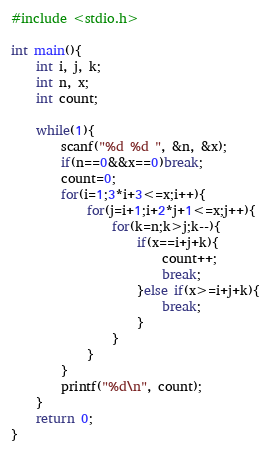<code> <loc_0><loc_0><loc_500><loc_500><_C_>#include <stdio.h>

int main(){
    int i, j, k;
    int n, x;
    int count;

    while(1){
        scanf("%d %d ", &n, &x);
        if(n==0&&x==0)break;
        count=0;
        for(i=1;3*i+3<=x;i++){
            for(j=i+1;i+2*j+1<=x;j++){
                for(k=n;k>j;k--){
                    if(x==i+j+k){
                        count++;
                        break;
                    }else if(x>=i+j+k){
                        break;
                    }
                }
            }
        }
        printf("%d\n", count);
    }
    return 0;
}
</code> 